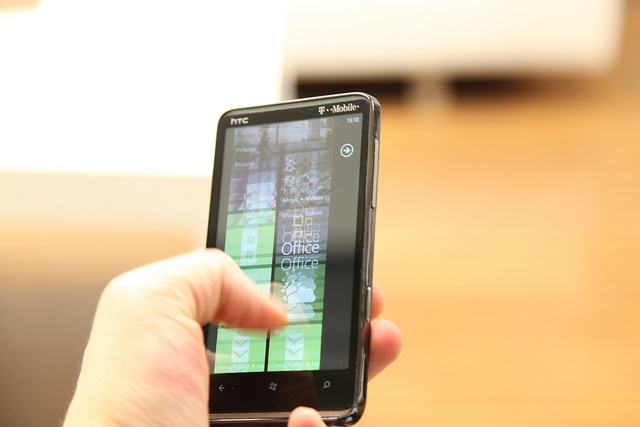Describe the objects in this image and their specific colors. I can see cell phone in tan, black, darkgray, gray, and lightgreen tones and people in tan, beige, and salmon tones in this image. 